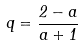Convert formula to latex. <formula><loc_0><loc_0><loc_500><loc_500>q = \frac { 2 - a } { a + 1 }</formula> 